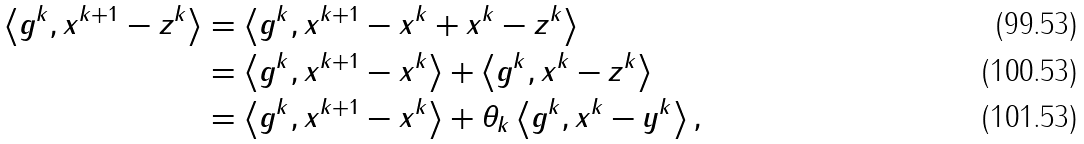Convert formula to latex. <formula><loc_0><loc_0><loc_500><loc_500>\left \langle g ^ { k } , x ^ { k + 1 } - z ^ { k } \right \rangle & = \left \langle g ^ { k } , x ^ { k + 1 } - x ^ { k } + x ^ { k } - z ^ { k } \right \rangle \\ & = \left \langle g ^ { k } , x ^ { k + 1 } - x ^ { k } \right \rangle + \left \langle g ^ { k } , x ^ { k } - z ^ { k } \right \rangle \\ & = \left \langle g ^ { k } , x ^ { k + 1 } - x ^ { k } \right \rangle + \theta _ { k } \left \langle g ^ { k } , x ^ { k } - y ^ { k } \right \rangle ,</formula> 